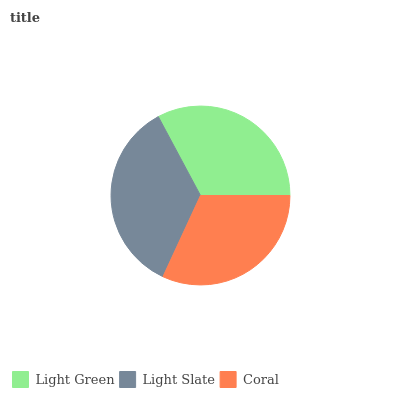Is Coral the minimum?
Answer yes or no. Yes. Is Light Slate the maximum?
Answer yes or no. Yes. Is Light Slate the minimum?
Answer yes or no. No. Is Coral the maximum?
Answer yes or no. No. Is Light Slate greater than Coral?
Answer yes or no. Yes. Is Coral less than Light Slate?
Answer yes or no. Yes. Is Coral greater than Light Slate?
Answer yes or no. No. Is Light Slate less than Coral?
Answer yes or no. No. Is Light Green the high median?
Answer yes or no. Yes. Is Light Green the low median?
Answer yes or no. Yes. Is Coral the high median?
Answer yes or no. No. Is Coral the low median?
Answer yes or no. No. 